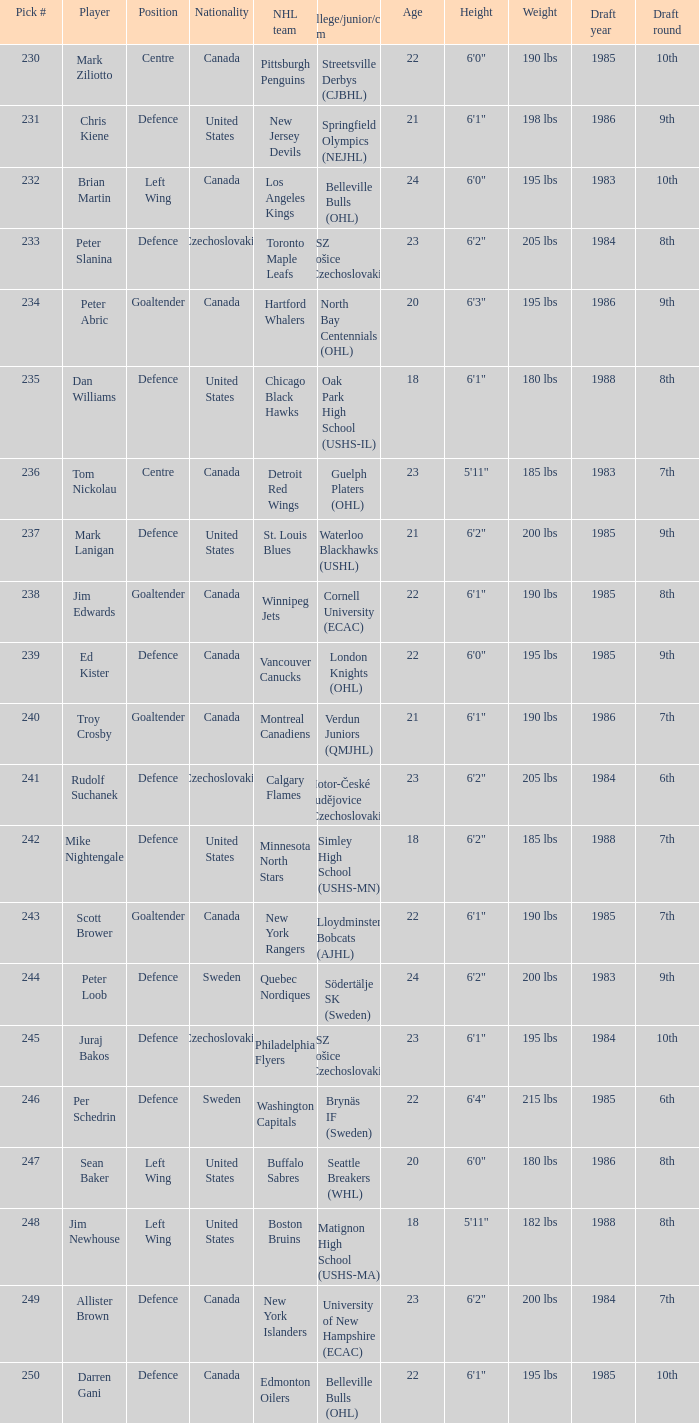What selection was the springfield olympics (nejhl)? 231.0. 